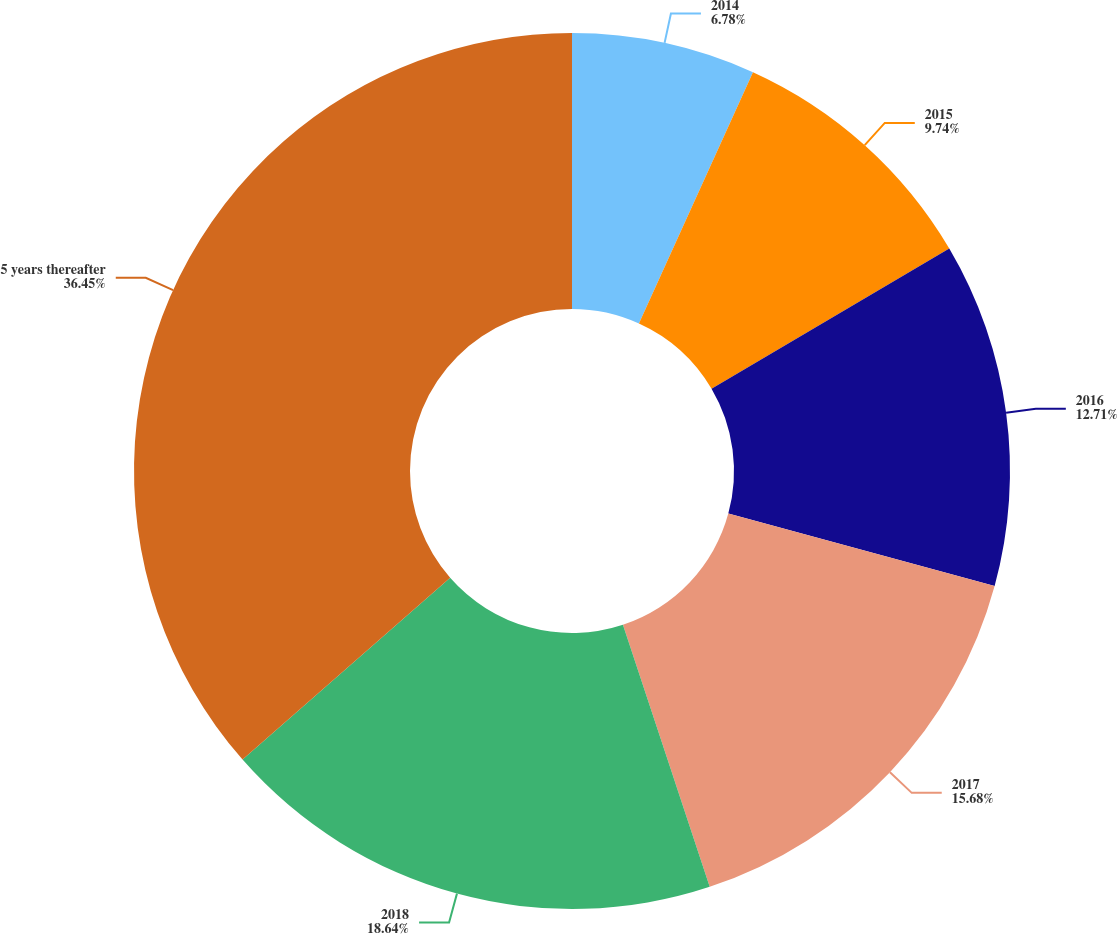<chart> <loc_0><loc_0><loc_500><loc_500><pie_chart><fcel>2014<fcel>2015<fcel>2016<fcel>2017<fcel>2018<fcel>5 years thereafter<nl><fcel>6.78%<fcel>9.74%<fcel>12.71%<fcel>15.68%<fcel>18.64%<fcel>36.45%<nl></chart> 